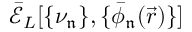<formula> <loc_0><loc_0><loc_500><loc_500>\mathcal { \bar { E } } _ { L } [ \{ \nu _ { \mathfrak { n } } \} , \{ \bar { \phi } _ { \mathfrak { n } } ( \vec { r } ) \} ]</formula> 